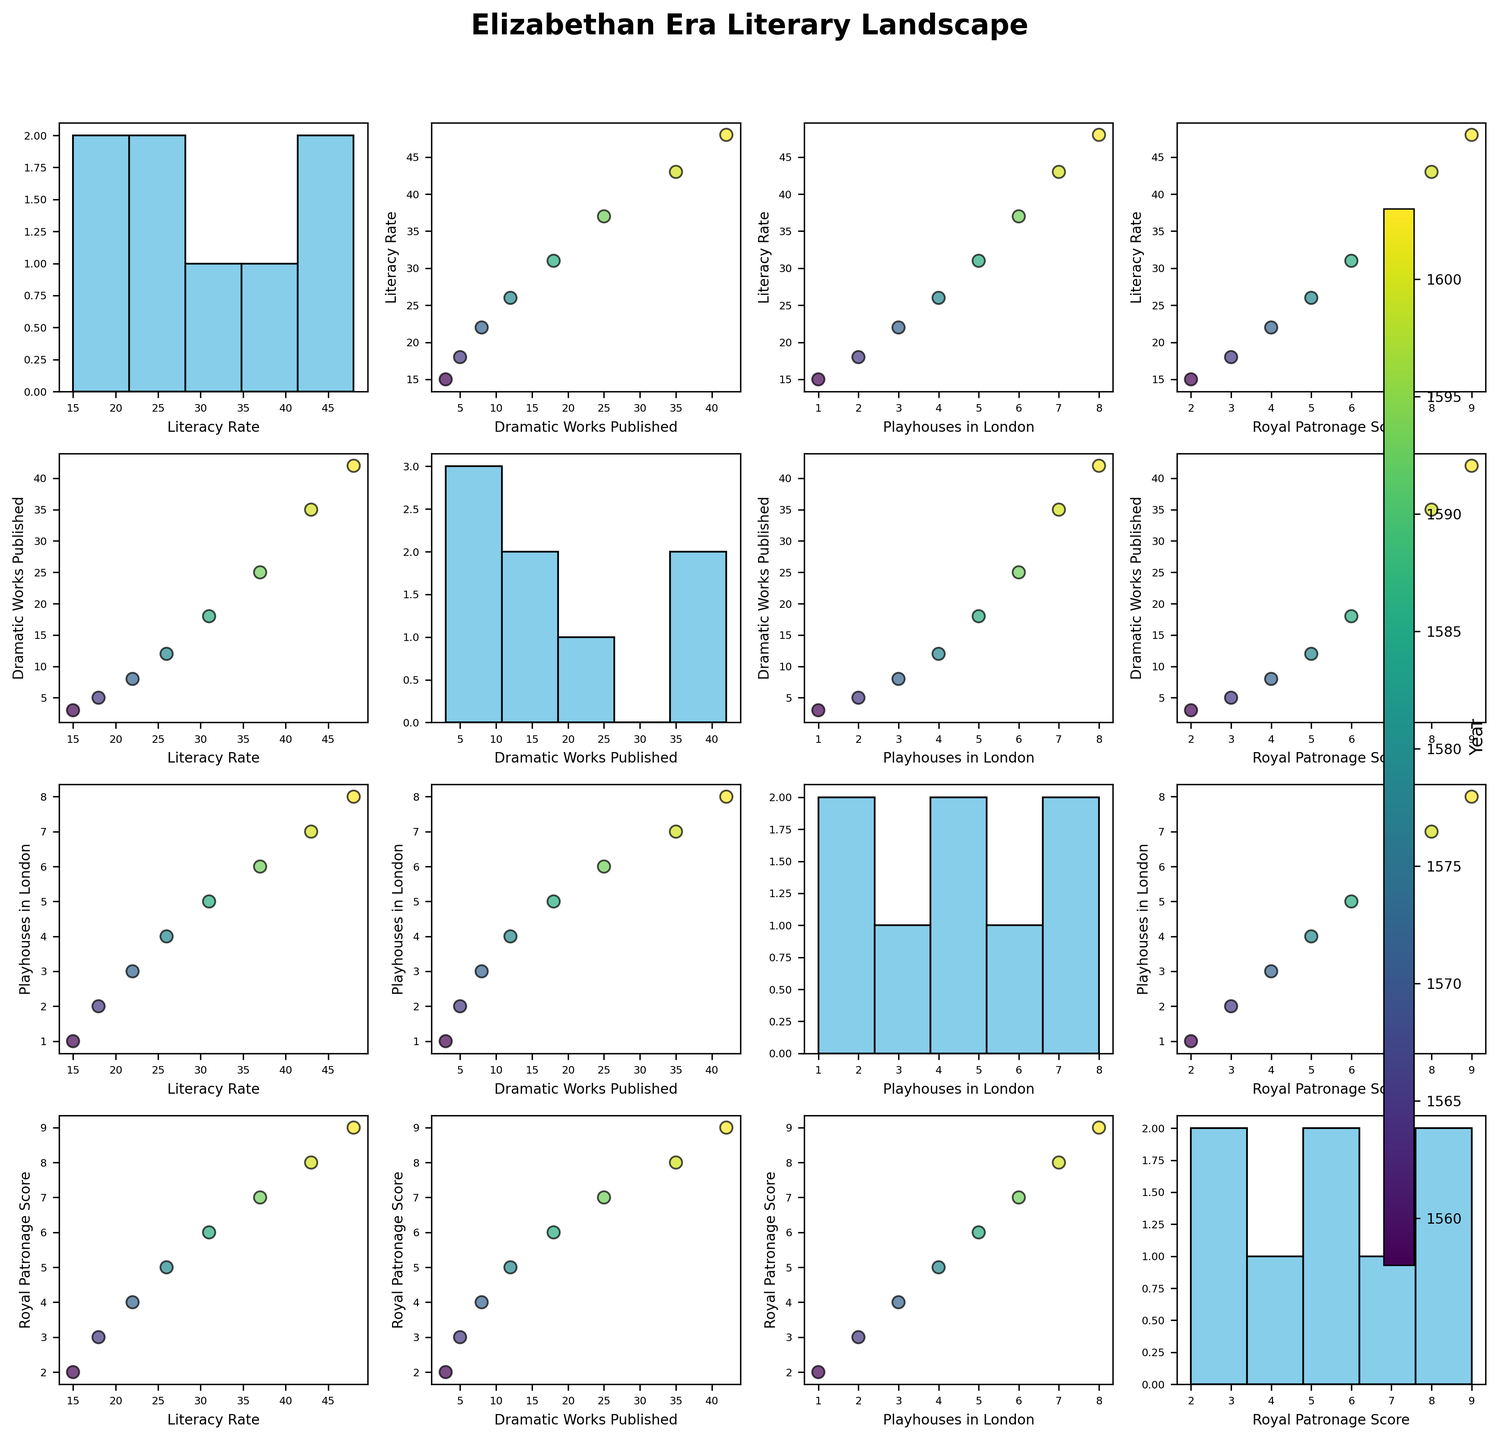What trends do you observe in the relationship between literacy rates and dramatic works published? The scatterplot matrix shows a strong positive correlation between literacy rates and dramatic works published. As literacy rates increase over the years, the number of dramatic works published also increases. This suggests that higher literacy rates may have contributed to a greater publication of dramatic works.
Answer: Positive correlation observed What is the trend in the number of playhouses in London over the years? From the scatterplots that include 'Playhouses_in_London', we see a gradual increase in the number of playhouses as the years progress. The data points for each year show a consistent upward trend indicating more playhouses being built over time.
Answer: Increasing trend How are literacy rates distributed over the years? The histogram for literacy rates shows a fairly normal distribution with an increase over the years. The highest frequencies are observed in the bins representing the end years of Elizabeth I's reign, with rising literacy trends.
Answer: Normal distribution, increasing trend Which variable shows the strongest correlation with literacy rates? By visually comparing the scatterplots involving Literacy_Rate, the strongest correlation appears to be with Dramatic_Works_Published, as indicated by a clear, upward trend line in the scatterplot for these two variables.
Answer: 'Dramatic_Works_Published' How does Royal Patronage Score influence the publication of dramatic works? The scatterplot matrix shows a positive correlation between 'Royal_Patronage_Score' and 'Dramatic_Works_Published'. As the Royal Patronage Score increases over the years, the number of dramatic works published also increases. This might indicate that royal patronage played an important role in the publication of dramatic works.
Answer: Positive influence What can you infer about the relationship between Royal Patronage Score and the number of playhouses in London? The scatterplot shows a positive correlation between 'Royal_Patronage_Score' and 'Playhouses_in_London'. As the patronage score increases, so does the number of playhouses, suggesting a supportive role of royal patronage in the growth of playhouses.
Answer: Positive correlation Which year has the highest number of dramatic works published? By examining the scatterplots and the data distribution across the years in the color-coded points, the year 1603 stands out as having the highest number of dramatic works published.
Answer: 1603 In which scatterplot do we see the least variation or scatter among the data points? The scatterplot between 'Royal_Patronage_Score' and 'Playhouses_in_London' shows the least variation among the data points since they appear to be closely clustered, indicating a strong linear relationship.
Answer: 'Royal_Patronage_Score' vs 'Playhouses_in_London' 